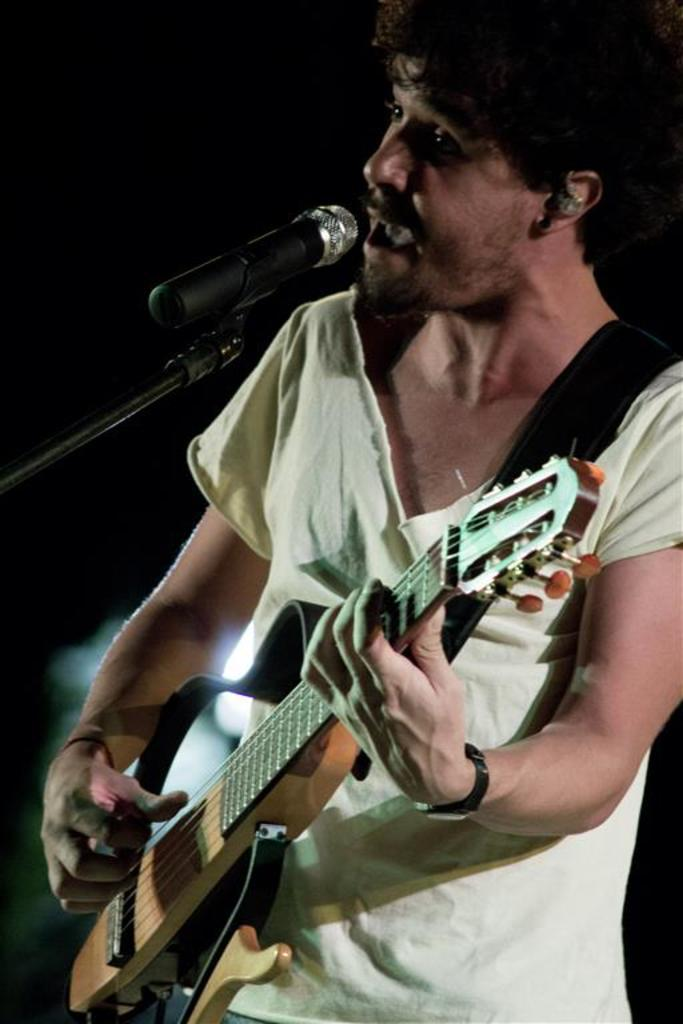What is the boy in the image doing? The boy is singing in the image. What instrument is the boy holding? The boy is holding a guitar in the image. What device is present for amplifying the boy's voice? There is a microphone in the image. Where is the boy positioned in the image? The boy is positioned at the right side of the image. Where is the microphone positioned in the image? The microphone is positioned at the left side of the image. What type of branch is the boy using to play the guitar in the image? There is no branch present in the image; the boy is holding a guitar, not a branch. 